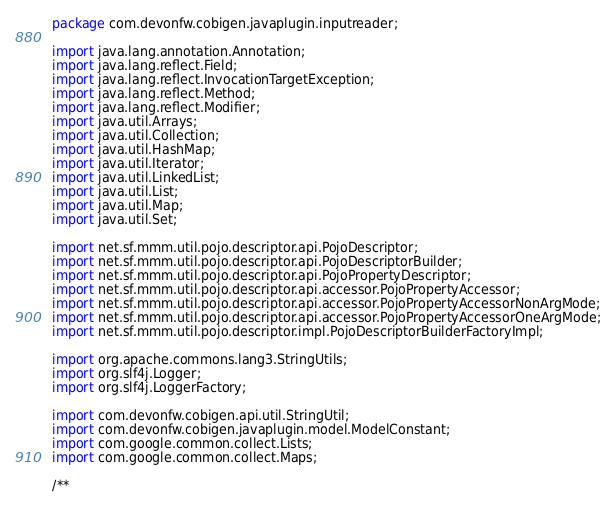Convert code to text. <code><loc_0><loc_0><loc_500><loc_500><_Java_>package com.devonfw.cobigen.javaplugin.inputreader;

import java.lang.annotation.Annotation;
import java.lang.reflect.Field;
import java.lang.reflect.InvocationTargetException;
import java.lang.reflect.Method;
import java.lang.reflect.Modifier;
import java.util.Arrays;
import java.util.Collection;
import java.util.HashMap;
import java.util.Iterator;
import java.util.LinkedList;
import java.util.List;
import java.util.Map;
import java.util.Set;

import net.sf.mmm.util.pojo.descriptor.api.PojoDescriptor;
import net.sf.mmm.util.pojo.descriptor.api.PojoDescriptorBuilder;
import net.sf.mmm.util.pojo.descriptor.api.PojoPropertyDescriptor;
import net.sf.mmm.util.pojo.descriptor.api.accessor.PojoPropertyAccessor;
import net.sf.mmm.util.pojo.descriptor.api.accessor.PojoPropertyAccessorNonArgMode;
import net.sf.mmm.util.pojo.descriptor.api.accessor.PojoPropertyAccessorOneArgMode;
import net.sf.mmm.util.pojo.descriptor.impl.PojoDescriptorBuilderFactoryImpl;

import org.apache.commons.lang3.StringUtils;
import org.slf4j.Logger;
import org.slf4j.LoggerFactory;

import com.devonfw.cobigen.api.util.StringUtil;
import com.devonfw.cobigen.javaplugin.model.ModelConstant;
import com.google.common.collect.Lists;
import com.google.common.collect.Maps;

/**</code> 